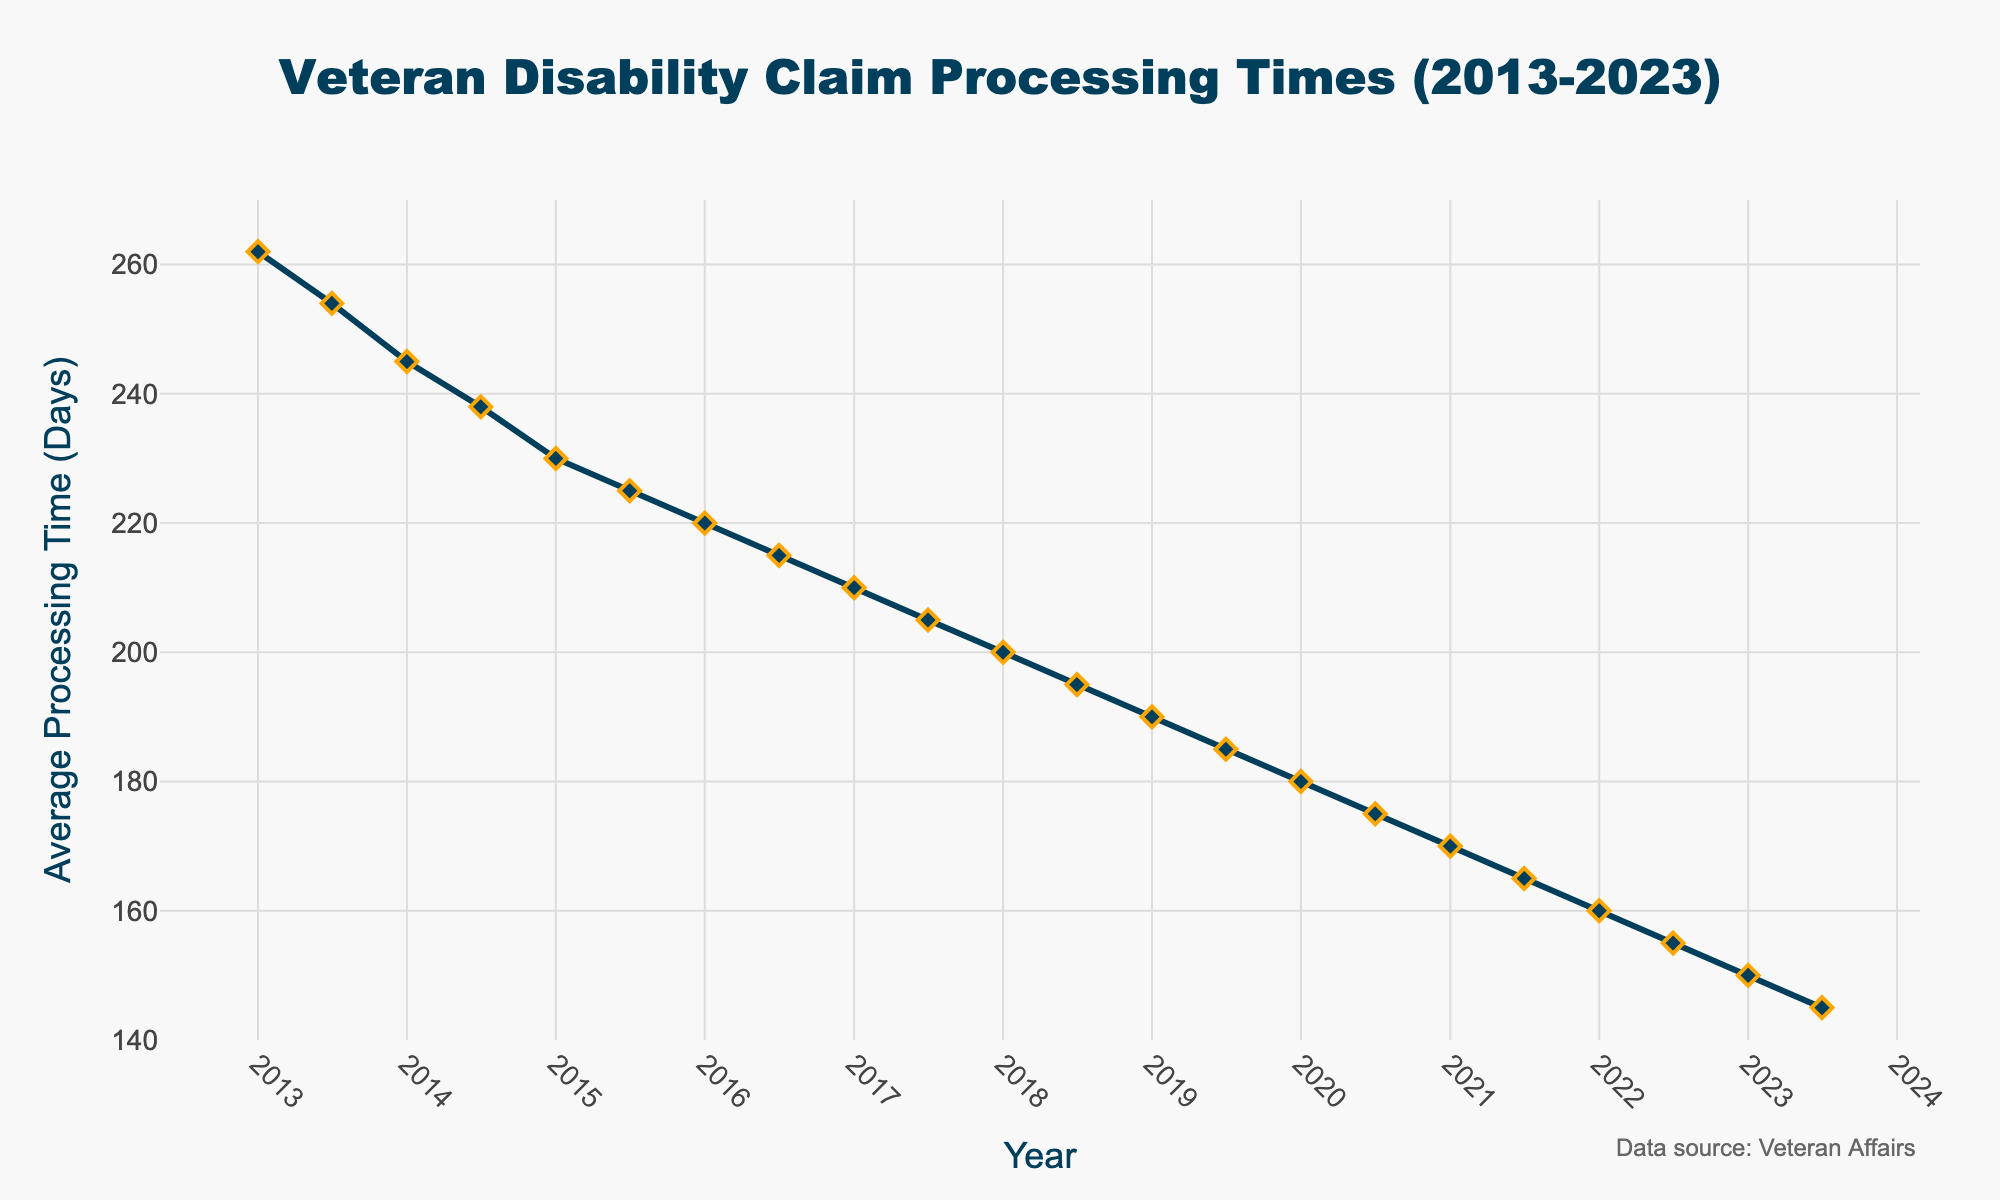What’s the trend in disability claim processing times from 2013 to 2023? The trend in the line chart shows a steady decline in the average processing time for disability claims from 2013 to 2023. Each year, the processing time consistently decreases.
Answer: Steady decline How does the processing time in July 2023 compare to January 2013? The processing time in July 2023 is 145 days, while in January 2013 it was 262 days. This means the processing time decreased by 117 days from January 2013 to July 2023.
Answer: Decreased by 117 days What is the percentage decrease in average processing time from January 2013 to July 2023? The processing time in January 2013 was 262 days, and in July 2023 it was 145 days. The decrease is 262 - 145 = 117 days. The percentage decrease is (117 / 262) * 100 ≈ 44.66%.
Answer: 44.66% In which year did the processing time drop below 200 days? From the chart, the processing time first dropped below 200 days in 2018.
Answer: 2018 Which month and year had the highest average processing time? The highest average processing time is observed in January 2013, with 262 days.
Answer: January 2013 What is the average processing time over the entire period? To find the average, sum all processing times and divide by the number of data points (22). Sum = 262 + 254 + ... + 145 = 4090 days. Average = 4090 / 22 ≈ 185.91 days.
Answer: 185.91 days How do processing times in July generally compare to January within the same year? On the chart, the processing times in July are always slightly lower than in January of the same year. For instance, in 2023, January is 150 days and July is 145 days. This pattern repeats for each year.
Answer: July is slightly lower What is the range of processing times recorded from 2013 to 2023? The range is the difference between the highest and lowest values. Highest: 262 days (January 2013), and Lowest: 145 days (July 2023). Range = 262 - 145 = 117 days.
Answer: 117 days Identify the period with the most rapid decline in processing times. By examining the slopes of the chart’s line segments, the steepest decline, indicating the most rapid drop, is from January 2013 to July 2013 (262 days to 254 days, 8 days over 6 months), and from 2022 to 2023.
Answer: January 2013 to July 2013 By how many days did the processing time decrease from January 2021 to July 2022? From the chart, the processing time in January 2021 was 170 days, and in July 2022 it was 155 days. The decrease is 170 - 155 = 15 days.
Answer: 15 days 